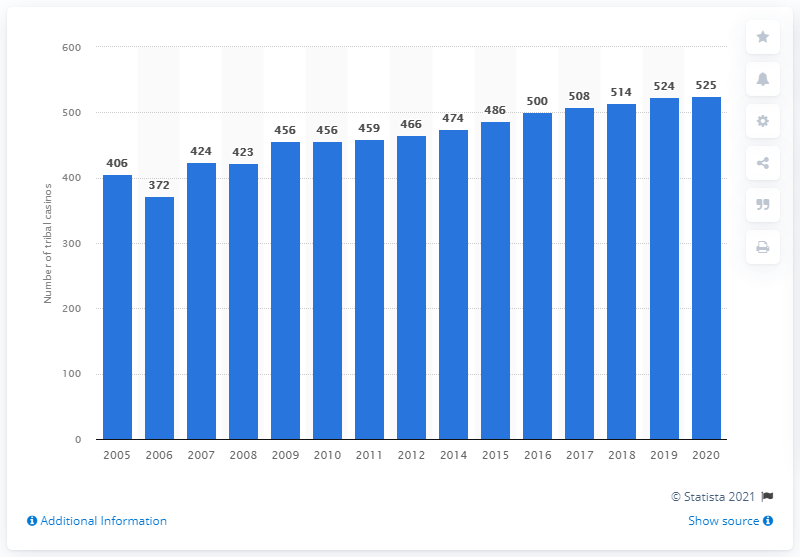Specify some key components in this picture. There were 525 tribal casinos in the United States in 2020. 